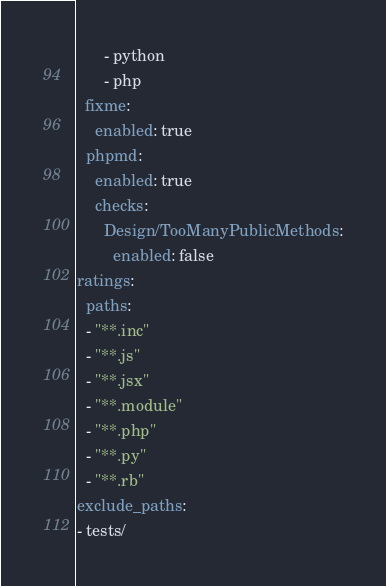Convert code to text. <code><loc_0><loc_0><loc_500><loc_500><_YAML_>      - python
      - php
  fixme:
    enabled: true
  phpmd:
    enabled: true
    checks:
      Design/TooManyPublicMethods:
        enabled: false
ratings:
  paths:
  - "**.inc"
  - "**.js"
  - "**.jsx"
  - "**.module"
  - "**.php"
  - "**.py"
  - "**.rb"
exclude_paths:
- tests/
</code> 